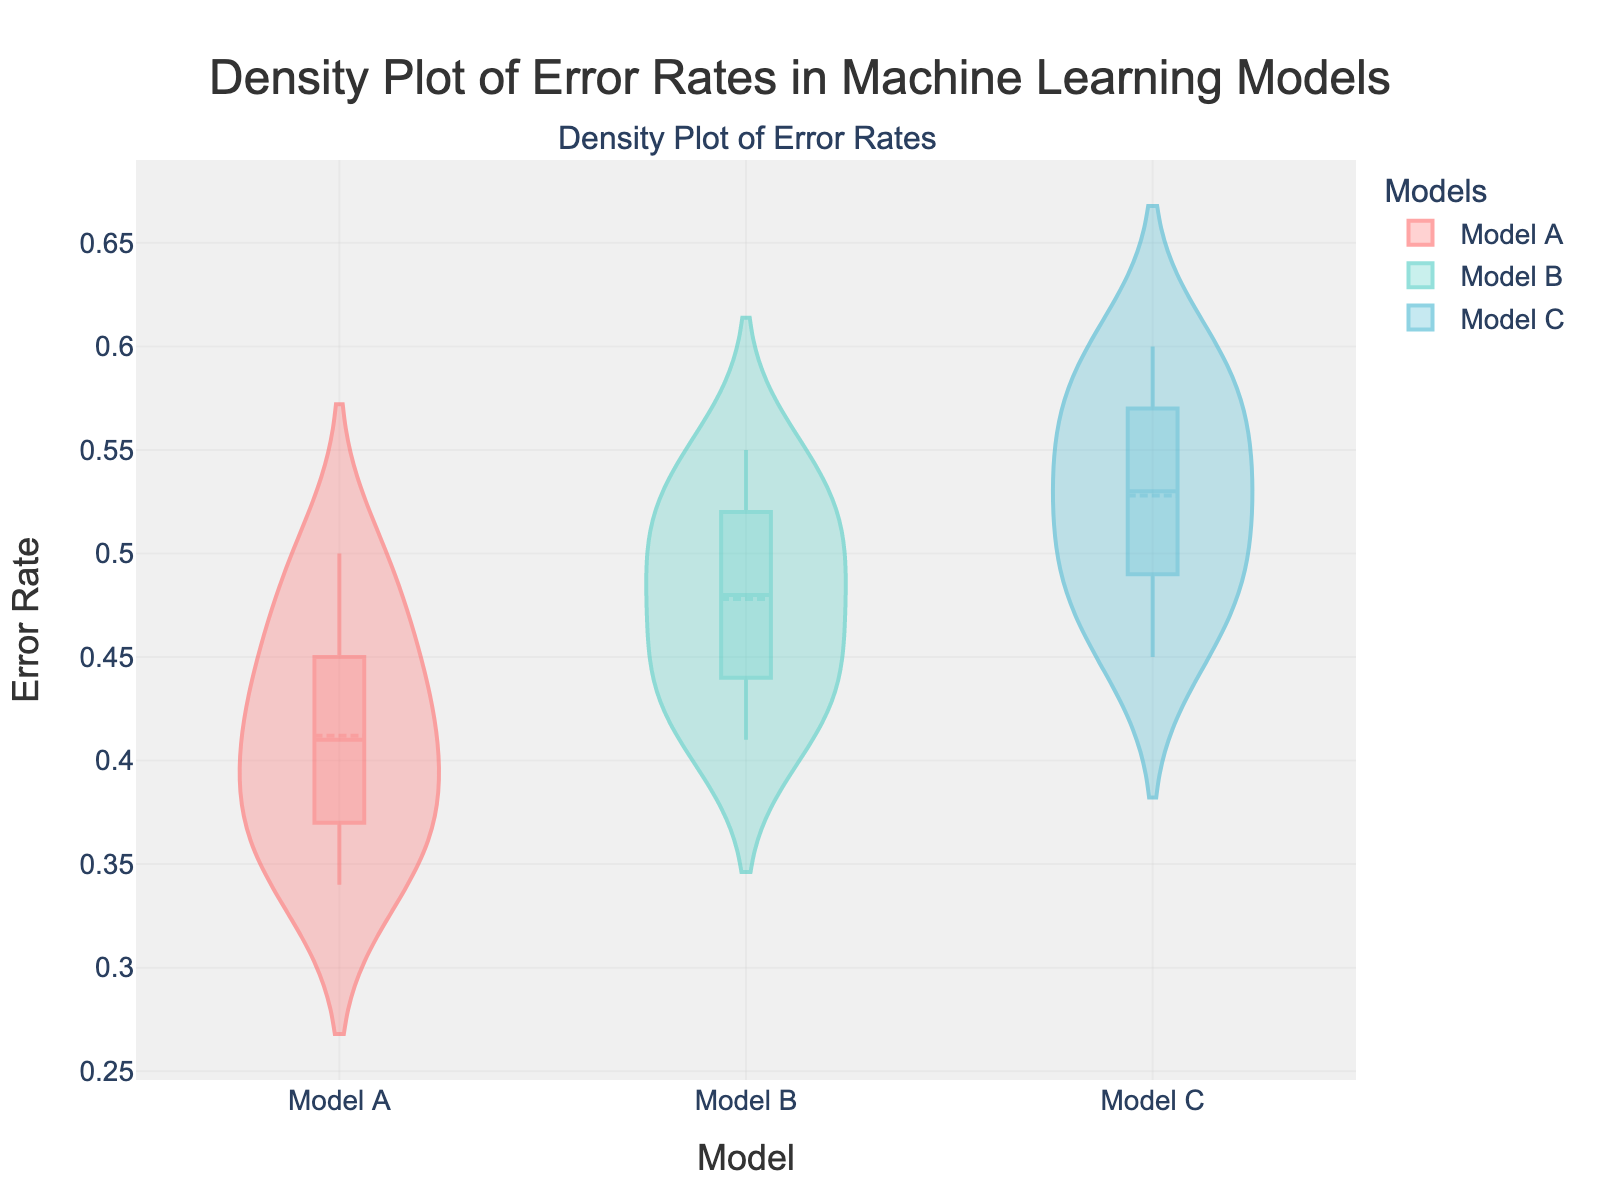What is the title of the plot? The title of the plot is clearly at the top of the figure. It reads "Density Plot of Error Rates in Machine Learning Models".
Answer: Density Plot of Error Rates in Machine Learning Models What do the colors in the plot represent? In the figure, the colors are associated with different machine learning models. Specifically, the color red represents Model A, teal represents Model B, and cyan represents Model C.
Answer: Different machine learning models Which model has the lowest median error rate? The plot shows a mean line for each model. By comparing these mean lines, it's evident that Model A has the lowest median error rate since its line is the lowest on the y-axis.
Answer: Model A How do the error rates of Model B compare to those of Model C? The error rates of Model B are generally lower than those of Model C. Both their density curves and boxplots (inside the violins) suggest that Model B has a consistently lower rate.
Answer: Lower What is the error rate range for Model A? The density plot's violin for Model A spreads from the highest error rate at approximately 0.50 to the lowest at approximately 0.34.
Answer: 0.34 to 0.50 How does the variability in error rates compare among the three models? By looking at the spread of the violins, one can see that Model A has the least variability, followed by Model B, while Model C has the most spread, indicating greater variability in error rates.
Answer: Model A < Model B < Model C Which model shows the least spread in its error rates? The violin representing Model A is the narrowest, indicating that Model A's error rates have the smallest spread.
Answer: Model A What is the approximate median error rate for Model C? The median error rate is represented by the mean line in the violin plot. For Model C, this is approximately around 0.52.
Answer: 0.52 Which model has the highest maximum error rate? The maximum error rate can be inferred from the topmost value in each violin plot. Model C has the highest maximum error rate because its violin extends the furthest upwards.
Answer: Model C 